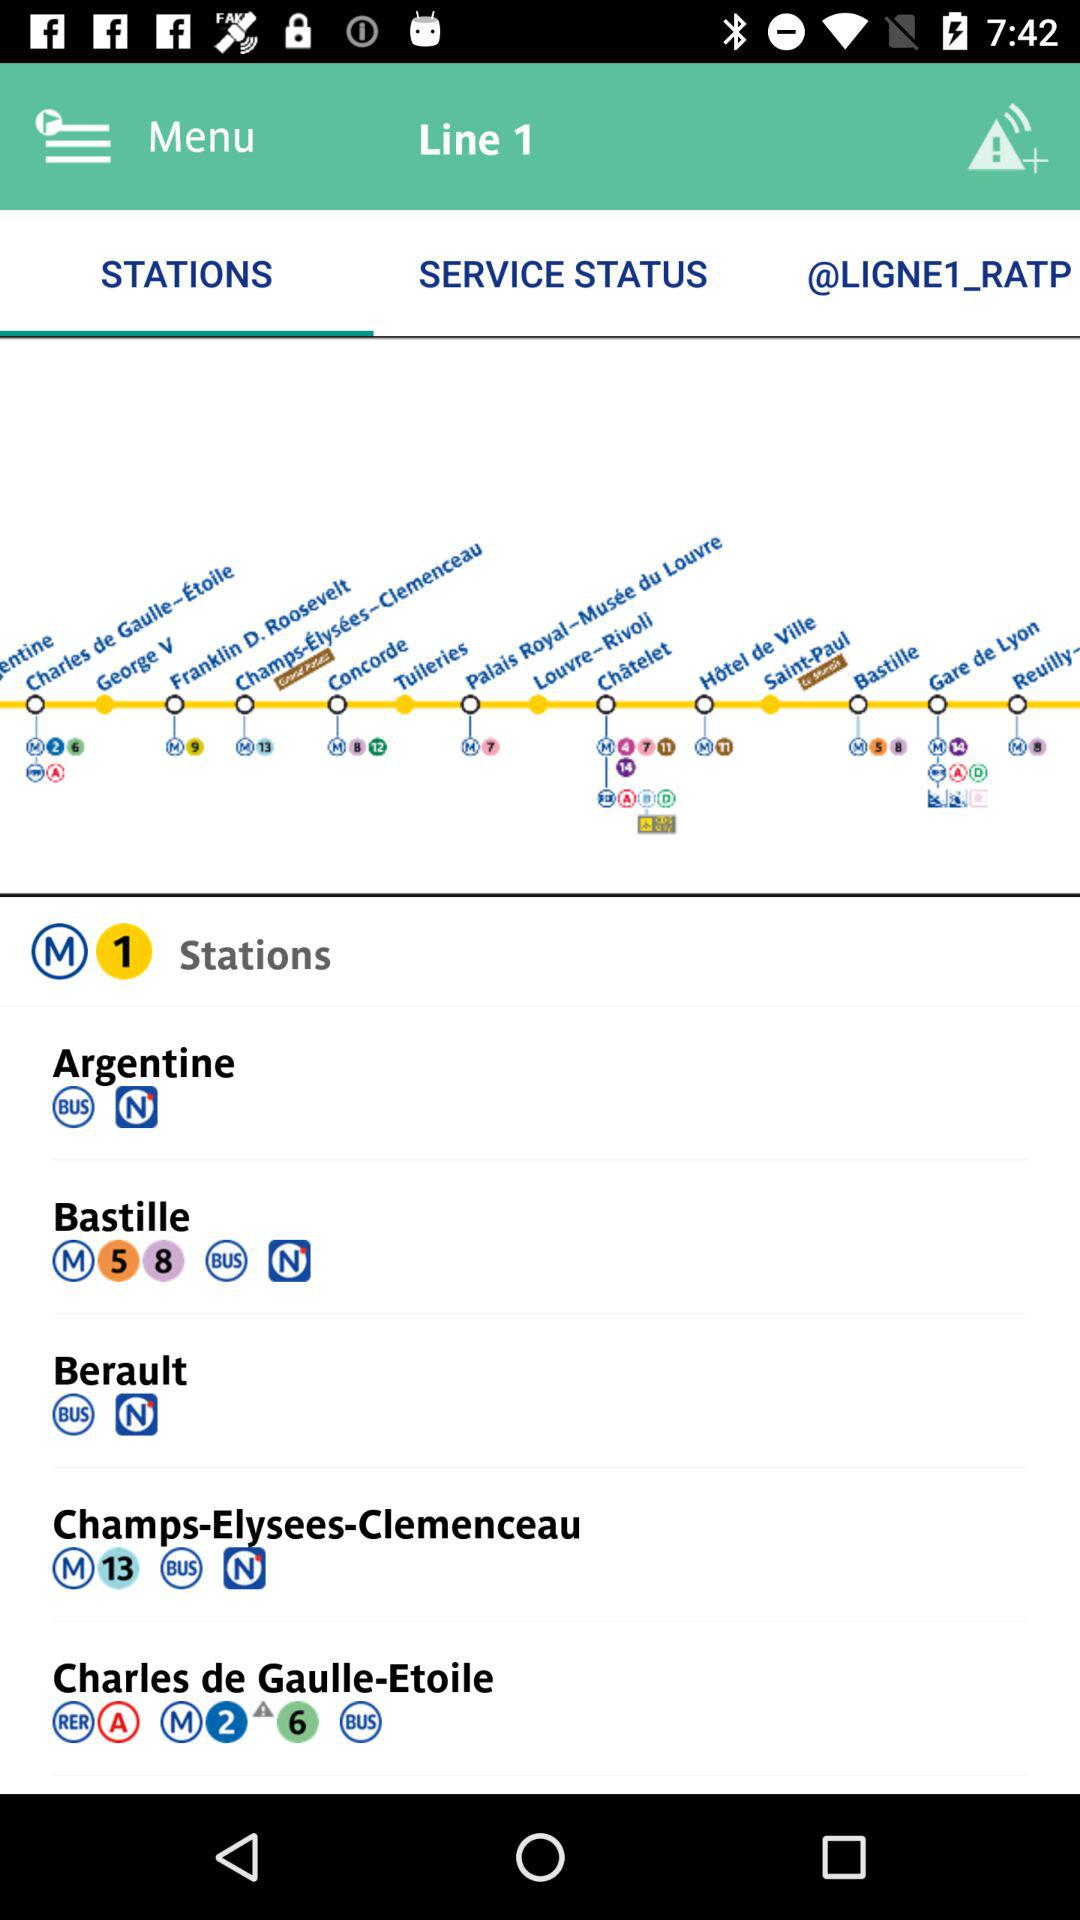How many items are in "SERVICE STATUS"?
When the provided information is insufficient, respond with <no answer>. <no answer> 